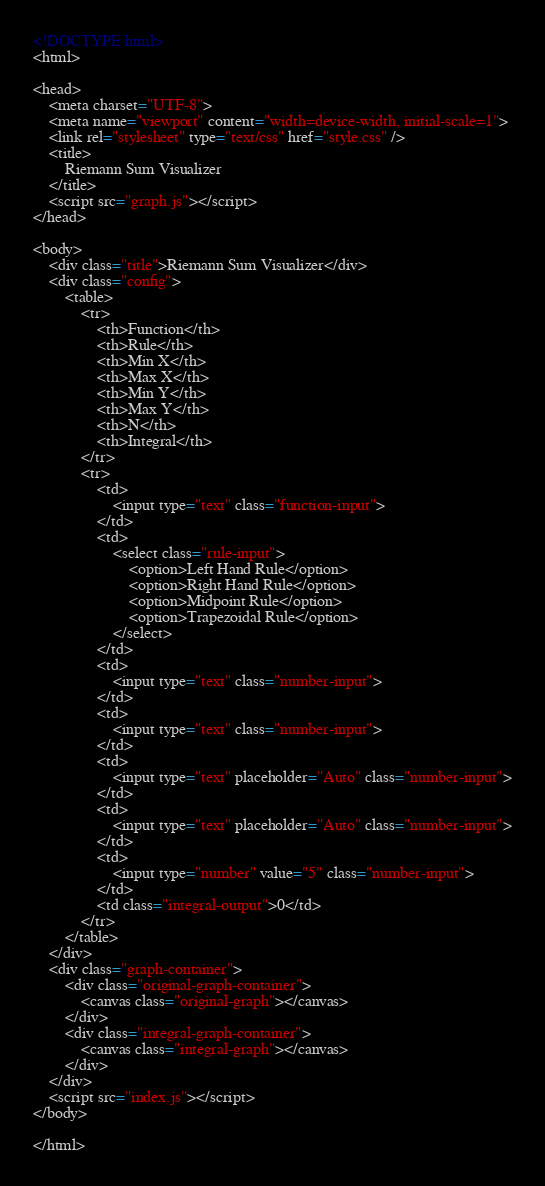<code> <loc_0><loc_0><loc_500><loc_500><_HTML_><!DOCTYPE html>
<html>

<head>
    <meta charset="UTF-8">
    <meta name="viewport" content="width=device-width, initial-scale=1">
    <link rel="stylesheet" type="text/css" href="style.css" />
    <title>
        Riemann Sum Visualizer
    </title>
    <script src="graph.js"></script>
</head>

<body>
    <div class="title">Riemann Sum Visualizer</div>
    <div class="config">
        <table>
            <tr>
                <th>Function</th>
                <th>Rule</th>
                <th>Min X</th>
                <th>Max X</th>
                <th>Min Y</th>
                <th>Max Y</th>
                <th>N</th>
                <th>Integral</th>
            </tr>
            <tr>
                <td>
                    <input type="text" class="function-input">
                </td>
                <td>
                    <select class="rule-input">
                        <option>Left Hand Rule</option>
                        <option>Right Hand Rule</option>
                        <option>Midpoint Rule</option>
                        <option>Trapezoidal Rule</option>
                    </select>
                </td>
                <td>
                    <input type="text" class="number-input">
                </td>
                <td>
                    <input type="text" class="number-input">
                </td>
                <td>
                    <input type="text" placeholder="Auto" class="number-input">
                </td>
                <td>
                    <input type="text" placeholder="Auto" class="number-input">
                </td>
                <td>
                    <input type="number" value="5" class="number-input">
                </td>
                <td class="integral-output">0</td>
            </tr>
        </table>
    </div>
    <div class="graph-container">
        <div class="original-graph-container">
            <canvas class="original-graph"></canvas>
        </div>
        <div class="integral-graph-container">
            <canvas class="integral-graph"></canvas>
        </div>
    </div>
    <script src="index.js"></script>
</body>

</html></code> 